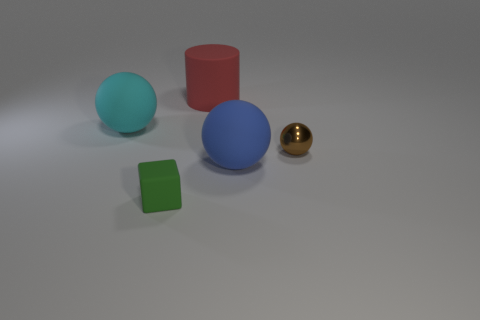Subtract all big balls. How many balls are left? 1 Subtract 1 balls. How many balls are left? 2 Add 4 small brown things. How many objects exist? 9 Subtract all blue balls. How many balls are left? 2 Add 4 large spheres. How many large spheres are left? 6 Add 4 large shiny spheres. How many large shiny spheres exist? 4 Subtract 0 red balls. How many objects are left? 5 Subtract all cubes. How many objects are left? 4 Subtract all red balls. Subtract all blue cubes. How many balls are left? 3 Subtract all cyan cubes. How many blue spheres are left? 1 